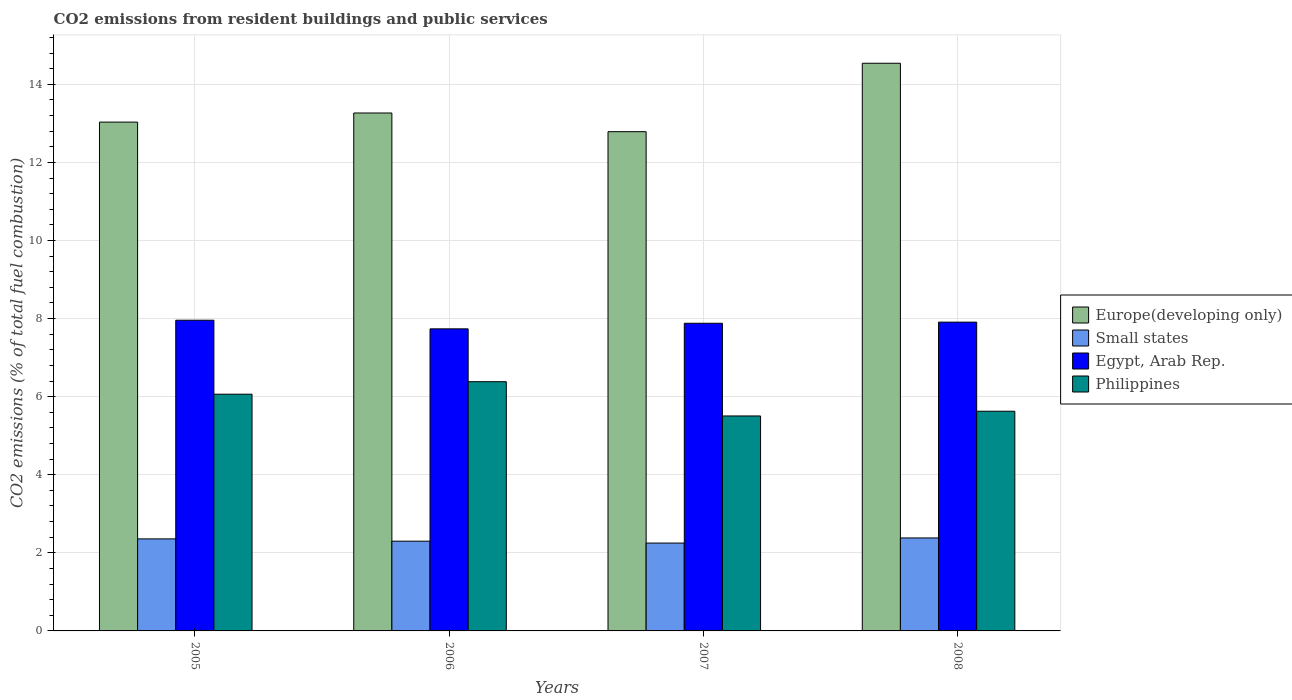How many different coloured bars are there?
Ensure brevity in your answer.  4. Are the number of bars per tick equal to the number of legend labels?
Your response must be concise. Yes. In how many cases, is the number of bars for a given year not equal to the number of legend labels?
Keep it short and to the point. 0. What is the total CO2 emitted in Philippines in 2007?
Ensure brevity in your answer.  5.51. Across all years, what is the maximum total CO2 emitted in Europe(developing only)?
Make the answer very short. 14.54. Across all years, what is the minimum total CO2 emitted in Europe(developing only)?
Give a very brief answer. 12.79. What is the total total CO2 emitted in Europe(developing only) in the graph?
Keep it short and to the point. 53.63. What is the difference between the total CO2 emitted in Egypt, Arab Rep. in 2006 and that in 2008?
Offer a very short reply. -0.17. What is the difference between the total CO2 emitted in Egypt, Arab Rep. in 2005 and the total CO2 emitted in Small states in 2006?
Offer a terse response. 5.66. What is the average total CO2 emitted in Europe(developing only) per year?
Offer a terse response. 13.41. In the year 2007, what is the difference between the total CO2 emitted in Europe(developing only) and total CO2 emitted in Small states?
Give a very brief answer. 10.54. In how many years, is the total CO2 emitted in Philippines greater than 12.4?
Your response must be concise. 0. What is the ratio of the total CO2 emitted in Small states in 2007 to that in 2008?
Make the answer very short. 0.94. What is the difference between the highest and the second highest total CO2 emitted in Europe(developing only)?
Keep it short and to the point. 1.27. What is the difference between the highest and the lowest total CO2 emitted in Small states?
Provide a succinct answer. 0.13. In how many years, is the total CO2 emitted in Europe(developing only) greater than the average total CO2 emitted in Europe(developing only) taken over all years?
Offer a terse response. 1. What does the 2nd bar from the left in 2005 represents?
Provide a succinct answer. Small states. What does the 3rd bar from the right in 2005 represents?
Keep it short and to the point. Small states. How many bars are there?
Your answer should be compact. 16. How many years are there in the graph?
Your answer should be compact. 4. Does the graph contain grids?
Provide a short and direct response. Yes. Where does the legend appear in the graph?
Offer a terse response. Center right. How many legend labels are there?
Provide a succinct answer. 4. How are the legend labels stacked?
Your response must be concise. Vertical. What is the title of the graph?
Make the answer very short. CO2 emissions from resident buildings and public services. Does "East Asia (developing only)" appear as one of the legend labels in the graph?
Provide a short and direct response. No. What is the label or title of the X-axis?
Offer a terse response. Years. What is the label or title of the Y-axis?
Ensure brevity in your answer.  CO2 emissions (% of total fuel combustion). What is the CO2 emissions (% of total fuel combustion) of Europe(developing only) in 2005?
Provide a short and direct response. 13.03. What is the CO2 emissions (% of total fuel combustion) in Small states in 2005?
Offer a very short reply. 2.36. What is the CO2 emissions (% of total fuel combustion) in Egypt, Arab Rep. in 2005?
Offer a terse response. 7.96. What is the CO2 emissions (% of total fuel combustion) in Philippines in 2005?
Keep it short and to the point. 6.06. What is the CO2 emissions (% of total fuel combustion) in Europe(developing only) in 2006?
Offer a very short reply. 13.27. What is the CO2 emissions (% of total fuel combustion) in Small states in 2006?
Keep it short and to the point. 2.3. What is the CO2 emissions (% of total fuel combustion) of Egypt, Arab Rep. in 2006?
Your response must be concise. 7.74. What is the CO2 emissions (% of total fuel combustion) of Philippines in 2006?
Make the answer very short. 6.38. What is the CO2 emissions (% of total fuel combustion) in Europe(developing only) in 2007?
Offer a very short reply. 12.79. What is the CO2 emissions (% of total fuel combustion) of Small states in 2007?
Provide a succinct answer. 2.25. What is the CO2 emissions (% of total fuel combustion) in Egypt, Arab Rep. in 2007?
Provide a short and direct response. 7.88. What is the CO2 emissions (% of total fuel combustion) in Philippines in 2007?
Keep it short and to the point. 5.51. What is the CO2 emissions (% of total fuel combustion) in Europe(developing only) in 2008?
Your response must be concise. 14.54. What is the CO2 emissions (% of total fuel combustion) of Small states in 2008?
Make the answer very short. 2.38. What is the CO2 emissions (% of total fuel combustion) of Egypt, Arab Rep. in 2008?
Your response must be concise. 7.91. What is the CO2 emissions (% of total fuel combustion) of Philippines in 2008?
Offer a terse response. 5.63. Across all years, what is the maximum CO2 emissions (% of total fuel combustion) in Europe(developing only)?
Keep it short and to the point. 14.54. Across all years, what is the maximum CO2 emissions (% of total fuel combustion) of Small states?
Offer a very short reply. 2.38. Across all years, what is the maximum CO2 emissions (% of total fuel combustion) of Egypt, Arab Rep.?
Keep it short and to the point. 7.96. Across all years, what is the maximum CO2 emissions (% of total fuel combustion) in Philippines?
Ensure brevity in your answer.  6.38. Across all years, what is the minimum CO2 emissions (% of total fuel combustion) of Europe(developing only)?
Provide a succinct answer. 12.79. Across all years, what is the minimum CO2 emissions (% of total fuel combustion) of Small states?
Provide a short and direct response. 2.25. Across all years, what is the minimum CO2 emissions (% of total fuel combustion) in Egypt, Arab Rep.?
Offer a very short reply. 7.74. Across all years, what is the minimum CO2 emissions (% of total fuel combustion) of Philippines?
Keep it short and to the point. 5.51. What is the total CO2 emissions (% of total fuel combustion) of Europe(developing only) in the graph?
Ensure brevity in your answer.  53.63. What is the total CO2 emissions (% of total fuel combustion) of Small states in the graph?
Make the answer very short. 9.29. What is the total CO2 emissions (% of total fuel combustion) of Egypt, Arab Rep. in the graph?
Your answer should be compact. 31.48. What is the total CO2 emissions (% of total fuel combustion) of Philippines in the graph?
Keep it short and to the point. 23.58. What is the difference between the CO2 emissions (% of total fuel combustion) of Europe(developing only) in 2005 and that in 2006?
Provide a short and direct response. -0.23. What is the difference between the CO2 emissions (% of total fuel combustion) of Small states in 2005 and that in 2006?
Your response must be concise. 0.06. What is the difference between the CO2 emissions (% of total fuel combustion) in Egypt, Arab Rep. in 2005 and that in 2006?
Offer a very short reply. 0.22. What is the difference between the CO2 emissions (% of total fuel combustion) in Philippines in 2005 and that in 2006?
Ensure brevity in your answer.  -0.32. What is the difference between the CO2 emissions (% of total fuel combustion) in Europe(developing only) in 2005 and that in 2007?
Your response must be concise. 0.25. What is the difference between the CO2 emissions (% of total fuel combustion) of Small states in 2005 and that in 2007?
Offer a very short reply. 0.11. What is the difference between the CO2 emissions (% of total fuel combustion) in Egypt, Arab Rep. in 2005 and that in 2007?
Keep it short and to the point. 0.08. What is the difference between the CO2 emissions (% of total fuel combustion) in Philippines in 2005 and that in 2007?
Your answer should be very brief. 0.56. What is the difference between the CO2 emissions (% of total fuel combustion) in Europe(developing only) in 2005 and that in 2008?
Your response must be concise. -1.51. What is the difference between the CO2 emissions (% of total fuel combustion) in Small states in 2005 and that in 2008?
Offer a terse response. -0.02. What is the difference between the CO2 emissions (% of total fuel combustion) of Egypt, Arab Rep. in 2005 and that in 2008?
Ensure brevity in your answer.  0.05. What is the difference between the CO2 emissions (% of total fuel combustion) in Philippines in 2005 and that in 2008?
Keep it short and to the point. 0.44. What is the difference between the CO2 emissions (% of total fuel combustion) in Europe(developing only) in 2006 and that in 2007?
Your response must be concise. 0.48. What is the difference between the CO2 emissions (% of total fuel combustion) of Small states in 2006 and that in 2007?
Give a very brief answer. 0.05. What is the difference between the CO2 emissions (% of total fuel combustion) in Egypt, Arab Rep. in 2006 and that in 2007?
Your response must be concise. -0.14. What is the difference between the CO2 emissions (% of total fuel combustion) of Philippines in 2006 and that in 2007?
Keep it short and to the point. 0.88. What is the difference between the CO2 emissions (% of total fuel combustion) in Europe(developing only) in 2006 and that in 2008?
Your response must be concise. -1.27. What is the difference between the CO2 emissions (% of total fuel combustion) in Small states in 2006 and that in 2008?
Ensure brevity in your answer.  -0.08. What is the difference between the CO2 emissions (% of total fuel combustion) of Egypt, Arab Rep. in 2006 and that in 2008?
Provide a short and direct response. -0.17. What is the difference between the CO2 emissions (% of total fuel combustion) of Philippines in 2006 and that in 2008?
Provide a short and direct response. 0.76. What is the difference between the CO2 emissions (% of total fuel combustion) in Europe(developing only) in 2007 and that in 2008?
Offer a terse response. -1.75. What is the difference between the CO2 emissions (% of total fuel combustion) of Small states in 2007 and that in 2008?
Your response must be concise. -0.13. What is the difference between the CO2 emissions (% of total fuel combustion) of Egypt, Arab Rep. in 2007 and that in 2008?
Ensure brevity in your answer.  -0.03. What is the difference between the CO2 emissions (% of total fuel combustion) in Philippines in 2007 and that in 2008?
Your answer should be very brief. -0.12. What is the difference between the CO2 emissions (% of total fuel combustion) in Europe(developing only) in 2005 and the CO2 emissions (% of total fuel combustion) in Small states in 2006?
Provide a short and direct response. 10.73. What is the difference between the CO2 emissions (% of total fuel combustion) of Europe(developing only) in 2005 and the CO2 emissions (% of total fuel combustion) of Egypt, Arab Rep. in 2006?
Offer a terse response. 5.3. What is the difference between the CO2 emissions (% of total fuel combustion) of Europe(developing only) in 2005 and the CO2 emissions (% of total fuel combustion) of Philippines in 2006?
Your answer should be compact. 6.65. What is the difference between the CO2 emissions (% of total fuel combustion) in Small states in 2005 and the CO2 emissions (% of total fuel combustion) in Egypt, Arab Rep. in 2006?
Make the answer very short. -5.38. What is the difference between the CO2 emissions (% of total fuel combustion) in Small states in 2005 and the CO2 emissions (% of total fuel combustion) in Philippines in 2006?
Your response must be concise. -4.03. What is the difference between the CO2 emissions (% of total fuel combustion) of Egypt, Arab Rep. in 2005 and the CO2 emissions (% of total fuel combustion) of Philippines in 2006?
Provide a short and direct response. 1.57. What is the difference between the CO2 emissions (% of total fuel combustion) of Europe(developing only) in 2005 and the CO2 emissions (% of total fuel combustion) of Small states in 2007?
Make the answer very short. 10.78. What is the difference between the CO2 emissions (% of total fuel combustion) of Europe(developing only) in 2005 and the CO2 emissions (% of total fuel combustion) of Egypt, Arab Rep. in 2007?
Ensure brevity in your answer.  5.15. What is the difference between the CO2 emissions (% of total fuel combustion) of Europe(developing only) in 2005 and the CO2 emissions (% of total fuel combustion) of Philippines in 2007?
Your answer should be very brief. 7.53. What is the difference between the CO2 emissions (% of total fuel combustion) of Small states in 2005 and the CO2 emissions (% of total fuel combustion) of Egypt, Arab Rep. in 2007?
Provide a succinct answer. -5.52. What is the difference between the CO2 emissions (% of total fuel combustion) of Small states in 2005 and the CO2 emissions (% of total fuel combustion) of Philippines in 2007?
Your answer should be very brief. -3.15. What is the difference between the CO2 emissions (% of total fuel combustion) in Egypt, Arab Rep. in 2005 and the CO2 emissions (% of total fuel combustion) in Philippines in 2007?
Keep it short and to the point. 2.45. What is the difference between the CO2 emissions (% of total fuel combustion) in Europe(developing only) in 2005 and the CO2 emissions (% of total fuel combustion) in Small states in 2008?
Provide a short and direct response. 10.65. What is the difference between the CO2 emissions (% of total fuel combustion) in Europe(developing only) in 2005 and the CO2 emissions (% of total fuel combustion) in Egypt, Arab Rep. in 2008?
Ensure brevity in your answer.  5.12. What is the difference between the CO2 emissions (% of total fuel combustion) of Europe(developing only) in 2005 and the CO2 emissions (% of total fuel combustion) of Philippines in 2008?
Offer a terse response. 7.41. What is the difference between the CO2 emissions (% of total fuel combustion) in Small states in 2005 and the CO2 emissions (% of total fuel combustion) in Egypt, Arab Rep. in 2008?
Ensure brevity in your answer.  -5.55. What is the difference between the CO2 emissions (% of total fuel combustion) in Small states in 2005 and the CO2 emissions (% of total fuel combustion) in Philippines in 2008?
Give a very brief answer. -3.27. What is the difference between the CO2 emissions (% of total fuel combustion) of Egypt, Arab Rep. in 2005 and the CO2 emissions (% of total fuel combustion) of Philippines in 2008?
Offer a very short reply. 2.33. What is the difference between the CO2 emissions (% of total fuel combustion) of Europe(developing only) in 2006 and the CO2 emissions (% of total fuel combustion) of Small states in 2007?
Provide a short and direct response. 11.02. What is the difference between the CO2 emissions (% of total fuel combustion) in Europe(developing only) in 2006 and the CO2 emissions (% of total fuel combustion) in Egypt, Arab Rep. in 2007?
Your response must be concise. 5.39. What is the difference between the CO2 emissions (% of total fuel combustion) in Europe(developing only) in 2006 and the CO2 emissions (% of total fuel combustion) in Philippines in 2007?
Ensure brevity in your answer.  7.76. What is the difference between the CO2 emissions (% of total fuel combustion) in Small states in 2006 and the CO2 emissions (% of total fuel combustion) in Egypt, Arab Rep. in 2007?
Keep it short and to the point. -5.58. What is the difference between the CO2 emissions (% of total fuel combustion) of Small states in 2006 and the CO2 emissions (% of total fuel combustion) of Philippines in 2007?
Provide a succinct answer. -3.21. What is the difference between the CO2 emissions (% of total fuel combustion) of Egypt, Arab Rep. in 2006 and the CO2 emissions (% of total fuel combustion) of Philippines in 2007?
Ensure brevity in your answer.  2.23. What is the difference between the CO2 emissions (% of total fuel combustion) in Europe(developing only) in 2006 and the CO2 emissions (% of total fuel combustion) in Small states in 2008?
Offer a terse response. 10.88. What is the difference between the CO2 emissions (% of total fuel combustion) in Europe(developing only) in 2006 and the CO2 emissions (% of total fuel combustion) in Egypt, Arab Rep. in 2008?
Make the answer very short. 5.36. What is the difference between the CO2 emissions (% of total fuel combustion) in Europe(developing only) in 2006 and the CO2 emissions (% of total fuel combustion) in Philippines in 2008?
Your response must be concise. 7.64. What is the difference between the CO2 emissions (% of total fuel combustion) in Small states in 2006 and the CO2 emissions (% of total fuel combustion) in Egypt, Arab Rep. in 2008?
Offer a terse response. -5.61. What is the difference between the CO2 emissions (% of total fuel combustion) in Small states in 2006 and the CO2 emissions (% of total fuel combustion) in Philippines in 2008?
Give a very brief answer. -3.33. What is the difference between the CO2 emissions (% of total fuel combustion) of Egypt, Arab Rep. in 2006 and the CO2 emissions (% of total fuel combustion) of Philippines in 2008?
Make the answer very short. 2.11. What is the difference between the CO2 emissions (% of total fuel combustion) in Europe(developing only) in 2007 and the CO2 emissions (% of total fuel combustion) in Small states in 2008?
Ensure brevity in your answer.  10.41. What is the difference between the CO2 emissions (% of total fuel combustion) in Europe(developing only) in 2007 and the CO2 emissions (% of total fuel combustion) in Egypt, Arab Rep. in 2008?
Provide a succinct answer. 4.88. What is the difference between the CO2 emissions (% of total fuel combustion) of Europe(developing only) in 2007 and the CO2 emissions (% of total fuel combustion) of Philippines in 2008?
Provide a succinct answer. 7.16. What is the difference between the CO2 emissions (% of total fuel combustion) of Small states in 2007 and the CO2 emissions (% of total fuel combustion) of Egypt, Arab Rep. in 2008?
Provide a succinct answer. -5.66. What is the difference between the CO2 emissions (% of total fuel combustion) in Small states in 2007 and the CO2 emissions (% of total fuel combustion) in Philippines in 2008?
Make the answer very short. -3.38. What is the difference between the CO2 emissions (% of total fuel combustion) of Egypt, Arab Rep. in 2007 and the CO2 emissions (% of total fuel combustion) of Philippines in 2008?
Your response must be concise. 2.25. What is the average CO2 emissions (% of total fuel combustion) in Europe(developing only) per year?
Ensure brevity in your answer.  13.41. What is the average CO2 emissions (% of total fuel combustion) in Small states per year?
Keep it short and to the point. 2.32. What is the average CO2 emissions (% of total fuel combustion) in Egypt, Arab Rep. per year?
Offer a very short reply. 7.87. What is the average CO2 emissions (% of total fuel combustion) of Philippines per year?
Your answer should be very brief. 5.89. In the year 2005, what is the difference between the CO2 emissions (% of total fuel combustion) in Europe(developing only) and CO2 emissions (% of total fuel combustion) in Small states?
Ensure brevity in your answer.  10.68. In the year 2005, what is the difference between the CO2 emissions (% of total fuel combustion) in Europe(developing only) and CO2 emissions (% of total fuel combustion) in Egypt, Arab Rep.?
Give a very brief answer. 5.07. In the year 2005, what is the difference between the CO2 emissions (% of total fuel combustion) in Europe(developing only) and CO2 emissions (% of total fuel combustion) in Philippines?
Ensure brevity in your answer.  6.97. In the year 2005, what is the difference between the CO2 emissions (% of total fuel combustion) of Small states and CO2 emissions (% of total fuel combustion) of Egypt, Arab Rep.?
Give a very brief answer. -5.6. In the year 2005, what is the difference between the CO2 emissions (% of total fuel combustion) in Small states and CO2 emissions (% of total fuel combustion) in Philippines?
Give a very brief answer. -3.71. In the year 2005, what is the difference between the CO2 emissions (% of total fuel combustion) in Egypt, Arab Rep. and CO2 emissions (% of total fuel combustion) in Philippines?
Your answer should be very brief. 1.89. In the year 2006, what is the difference between the CO2 emissions (% of total fuel combustion) of Europe(developing only) and CO2 emissions (% of total fuel combustion) of Small states?
Give a very brief answer. 10.97. In the year 2006, what is the difference between the CO2 emissions (% of total fuel combustion) in Europe(developing only) and CO2 emissions (% of total fuel combustion) in Egypt, Arab Rep.?
Give a very brief answer. 5.53. In the year 2006, what is the difference between the CO2 emissions (% of total fuel combustion) in Europe(developing only) and CO2 emissions (% of total fuel combustion) in Philippines?
Make the answer very short. 6.88. In the year 2006, what is the difference between the CO2 emissions (% of total fuel combustion) in Small states and CO2 emissions (% of total fuel combustion) in Egypt, Arab Rep.?
Provide a short and direct response. -5.44. In the year 2006, what is the difference between the CO2 emissions (% of total fuel combustion) in Small states and CO2 emissions (% of total fuel combustion) in Philippines?
Your answer should be compact. -4.08. In the year 2006, what is the difference between the CO2 emissions (% of total fuel combustion) in Egypt, Arab Rep. and CO2 emissions (% of total fuel combustion) in Philippines?
Offer a very short reply. 1.35. In the year 2007, what is the difference between the CO2 emissions (% of total fuel combustion) of Europe(developing only) and CO2 emissions (% of total fuel combustion) of Small states?
Ensure brevity in your answer.  10.54. In the year 2007, what is the difference between the CO2 emissions (% of total fuel combustion) in Europe(developing only) and CO2 emissions (% of total fuel combustion) in Egypt, Arab Rep.?
Your answer should be very brief. 4.91. In the year 2007, what is the difference between the CO2 emissions (% of total fuel combustion) in Europe(developing only) and CO2 emissions (% of total fuel combustion) in Philippines?
Offer a very short reply. 7.28. In the year 2007, what is the difference between the CO2 emissions (% of total fuel combustion) of Small states and CO2 emissions (% of total fuel combustion) of Egypt, Arab Rep.?
Ensure brevity in your answer.  -5.63. In the year 2007, what is the difference between the CO2 emissions (% of total fuel combustion) in Small states and CO2 emissions (% of total fuel combustion) in Philippines?
Keep it short and to the point. -3.26. In the year 2007, what is the difference between the CO2 emissions (% of total fuel combustion) in Egypt, Arab Rep. and CO2 emissions (% of total fuel combustion) in Philippines?
Ensure brevity in your answer.  2.37. In the year 2008, what is the difference between the CO2 emissions (% of total fuel combustion) in Europe(developing only) and CO2 emissions (% of total fuel combustion) in Small states?
Offer a terse response. 12.16. In the year 2008, what is the difference between the CO2 emissions (% of total fuel combustion) in Europe(developing only) and CO2 emissions (% of total fuel combustion) in Egypt, Arab Rep.?
Offer a terse response. 6.63. In the year 2008, what is the difference between the CO2 emissions (% of total fuel combustion) in Europe(developing only) and CO2 emissions (% of total fuel combustion) in Philippines?
Your answer should be very brief. 8.91. In the year 2008, what is the difference between the CO2 emissions (% of total fuel combustion) in Small states and CO2 emissions (% of total fuel combustion) in Egypt, Arab Rep.?
Your answer should be very brief. -5.53. In the year 2008, what is the difference between the CO2 emissions (% of total fuel combustion) in Small states and CO2 emissions (% of total fuel combustion) in Philippines?
Provide a succinct answer. -3.25. In the year 2008, what is the difference between the CO2 emissions (% of total fuel combustion) of Egypt, Arab Rep. and CO2 emissions (% of total fuel combustion) of Philippines?
Keep it short and to the point. 2.28. What is the ratio of the CO2 emissions (% of total fuel combustion) in Europe(developing only) in 2005 to that in 2006?
Keep it short and to the point. 0.98. What is the ratio of the CO2 emissions (% of total fuel combustion) of Small states in 2005 to that in 2006?
Provide a short and direct response. 1.03. What is the ratio of the CO2 emissions (% of total fuel combustion) in Egypt, Arab Rep. in 2005 to that in 2006?
Offer a very short reply. 1.03. What is the ratio of the CO2 emissions (% of total fuel combustion) of Philippines in 2005 to that in 2006?
Your response must be concise. 0.95. What is the ratio of the CO2 emissions (% of total fuel combustion) of Europe(developing only) in 2005 to that in 2007?
Your response must be concise. 1.02. What is the ratio of the CO2 emissions (% of total fuel combustion) in Small states in 2005 to that in 2007?
Offer a terse response. 1.05. What is the ratio of the CO2 emissions (% of total fuel combustion) of Egypt, Arab Rep. in 2005 to that in 2007?
Offer a very short reply. 1.01. What is the ratio of the CO2 emissions (% of total fuel combustion) in Philippines in 2005 to that in 2007?
Make the answer very short. 1.1. What is the ratio of the CO2 emissions (% of total fuel combustion) in Europe(developing only) in 2005 to that in 2008?
Your answer should be compact. 0.9. What is the ratio of the CO2 emissions (% of total fuel combustion) of Egypt, Arab Rep. in 2005 to that in 2008?
Keep it short and to the point. 1.01. What is the ratio of the CO2 emissions (% of total fuel combustion) of Philippines in 2005 to that in 2008?
Ensure brevity in your answer.  1.08. What is the ratio of the CO2 emissions (% of total fuel combustion) in Europe(developing only) in 2006 to that in 2007?
Provide a succinct answer. 1.04. What is the ratio of the CO2 emissions (% of total fuel combustion) in Small states in 2006 to that in 2007?
Your response must be concise. 1.02. What is the ratio of the CO2 emissions (% of total fuel combustion) of Egypt, Arab Rep. in 2006 to that in 2007?
Provide a short and direct response. 0.98. What is the ratio of the CO2 emissions (% of total fuel combustion) of Philippines in 2006 to that in 2007?
Keep it short and to the point. 1.16. What is the ratio of the CO2 emissions (% of total fuel combustion) of Europe(developing only) in 2006 to that in 2008?
Your answer should be compact. 0.91. What is the ratio of the CO2 emissions (% of total fuel combustion) of Small states in 2006 to that in 2008?
Your response must be concise. 0.97. What is the ratio of the CO2 emissions (% of total fuel combustion) of Egypt, Arab Rep. in 2006 to that in 2008?
Provide a succinct answer. 0.98. What is the ratio of the CO2 emissions (% of total fuel combustion) of Philippines in 2006 to that in 2008?
Your answer should be compact. 1.13. What is the ratio of the CO2 emissions (% of total fuel combustion) in Europe(developing only) in 2007 to that in 2008?
Your answer should be very brief. 0.88. What is the ratio of the CO2 emissions (% of total fuel combustion) of Small states in 2007 to that in 2008?
Your response must be concise. 0.94. What is the ratio of the CO2 emissions (% of total fuel combustion) of Egypt, Arab Rep. in 2007 to that in 2008?
Give a very brief answer. 1. What is the ratio of the CO2 emissions (% of total fuel combustion) of Philippines in 2007 to that in 2008?
Give a very brief answer. 0.98. What is the difference between the highest and the second highest CO2 emissions (% of total fuel combustion) of Europe(developing only)?
Your answer should be compact. 1.27. What is the difference between the highest and the second highest CO2 emissions (% of total fuel combustion) of Small states?
Your answer should be compact. 0.02. What is the difference between the highest and the second highest CO2 emissions (% of total fuel combustion) in Egypt, Arab Rep.?
Keep it short and to the point. 0.05. What is the difference between the highest and the second highest CO2 emissions (% of total fuel combustion) in Philippines?
Provide a succinct answer. 0.32. What is the difference between the highest and the lowest CO2 emissions (% of total fuel combustion) in Europe(developing only)?
Offer a very short reply. 1.75. What is the difference between the highest and the lowest CO2 emissions (% of total fuel combustion) of Small states?
Provide a short and direct response. 0.13. What is the difference between the highest and the lowest CO2 emissions (% of total fuel combustion) in Egypt, Arab Rep.?
Provide a short and direct response. 0.22. What is the difference between the highest and the lowest CO2 emissions (% of total fuel combustion) in Philippines?
Provide a succinct answer. 0.88. 